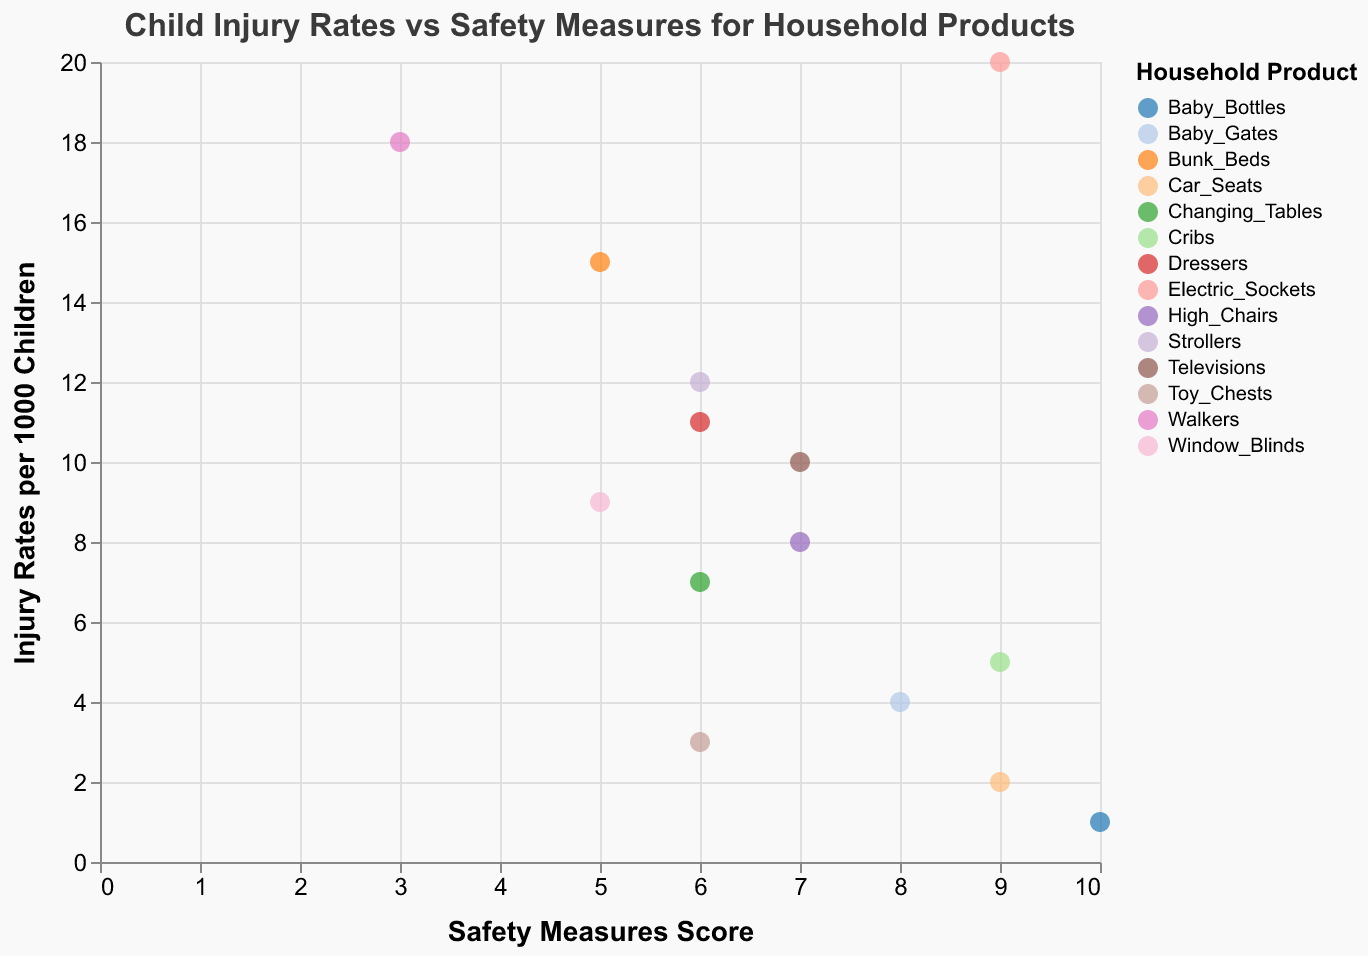How many household products have injury rates greater than 10 per 1000 children? To determine this, we count the data points (household products) where "Injury Rates per 1000 Children" is greater than 10. The products that meet this criterion are Strollers, Bunk_Beds, Walkers, Electric_Sockets, and Dressers. Thus, there are 5 products.
Answer: 5 Which household product has the highest safety measures score? From the scatter plot, we observe the data point with the highest "Safety Measures Score." The highest score is 10, which belongs to Baby_Bottles.
Answer: Baby_Bottles Is there any household product with both high safety measures score (8 and above) and low injury rates (5 and below)? To find such a product, we look for a data point with "Safety Measures Score" of at least 8 and injury rates of at most 5. The products meeting these criteria are Baby_Gates, Car_Seats, and Cribs.
Answer: Baby_Gates, Car_Seats, Cribs Which two products have the closest injury rates but different safety measures scores? By examining the plot, we find Baby_Gates (4 injuries) and Cribs (5 injuries) have close injury rates yet different safety measures scores (Baby_Gates 8, Cribs 9).
Answer: Baby_Gates and Cribs What is the relationship between injury rates and safety measures for Electric_Sockets and Car_Seats? Electric_Sockets have an injury rate of 20 with a safety score of 9, whereas Car_Seats have an injury rate of 2 with the same safety score of 9. This suggests even with high safety scores, injury rates can vary significantly.
Answer: High injury rate for Electric_Sockets and low for Car_Seats with the same safety score 